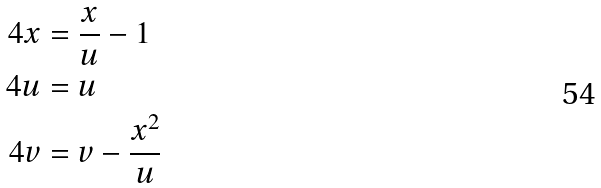<formula> <loc_0><loc_0><loc_500><loc_500>\ 4 x & = \frac { x } { u } - 1 \\ \ 4 u & = u \\ \ 4 v & = v - \frac { x ^ { 2 } } { u }</formula> 